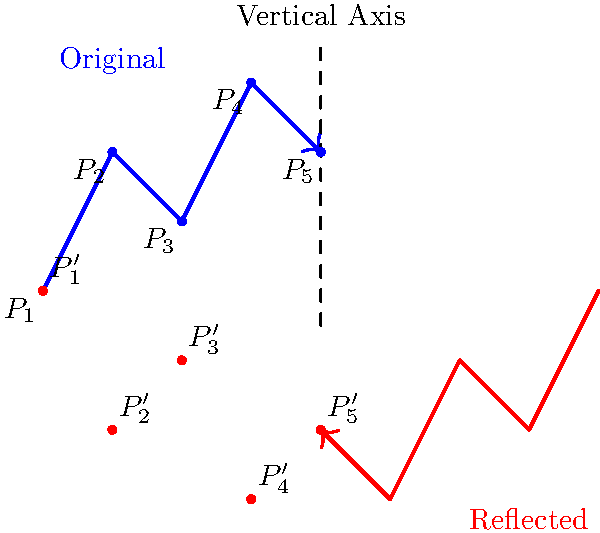When reflecting the shape of the Andes mountain range across a vertical axis, which of the following statements is true about the coordinates of the reflected points? To understand how the reflection across a vertical axis affects the coordinates, let's follow these steps:

1. In a reflection across a vertical axis, the x-coordinate changes sign, while the y-coordinate remains the same.

2. For any point $(x, y)$, its reflection across the vertical axis will be $(-x, y)$.

3. Looking at the original points in blue:
   $P_1(-4, 0)$, $P_2(-3, 2)$, $P_3(-2, 1)$, $P_4(-1, 3)$, $P_5(0, 2)$

4. The reflected points in red will be:
   $P_1'(4, 0)$, $P_2'(3, 2)$, $P_3'(2, 1)$, $P_4'(1, 3)$, $P_5'(0, 2)$

5. Observing the changes:
   - The x-coordinates have changed from negative to positive (except for $P_5$ which was already on the axis).
   - The y-coordinates have remained the same.
   - The overall shape is mirrored, appearing as a reflection of the original.

Therefore, in a reflection across a vertical axis, the x-coordinates change sign while the y-coordinates remain unchanged.
Answer: The x-coordinates change sign, y-coordinates remain the same. 